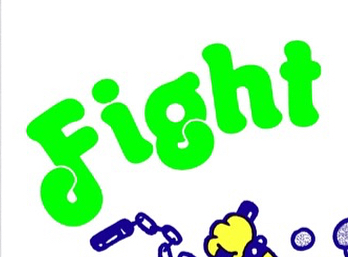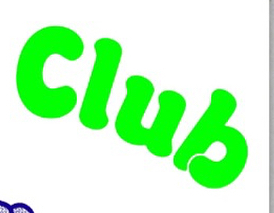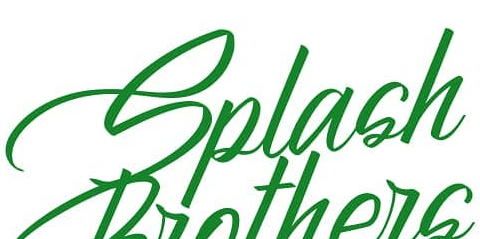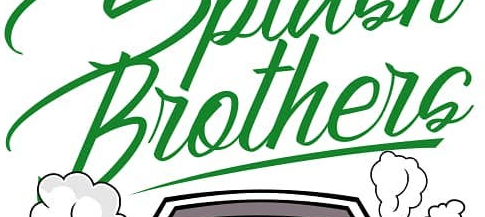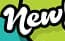What words can you see in these images in sequence, separated by a semicolon? Fight; Club; Splash; Brothers; New 